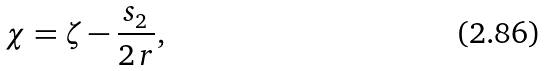Convert formula to latex. <formula><loc_0><loc_0><loc_500><loc_500>\chi = \zeta - \frac { s _ { 2 } } { 2 \, r } ,</formula> 